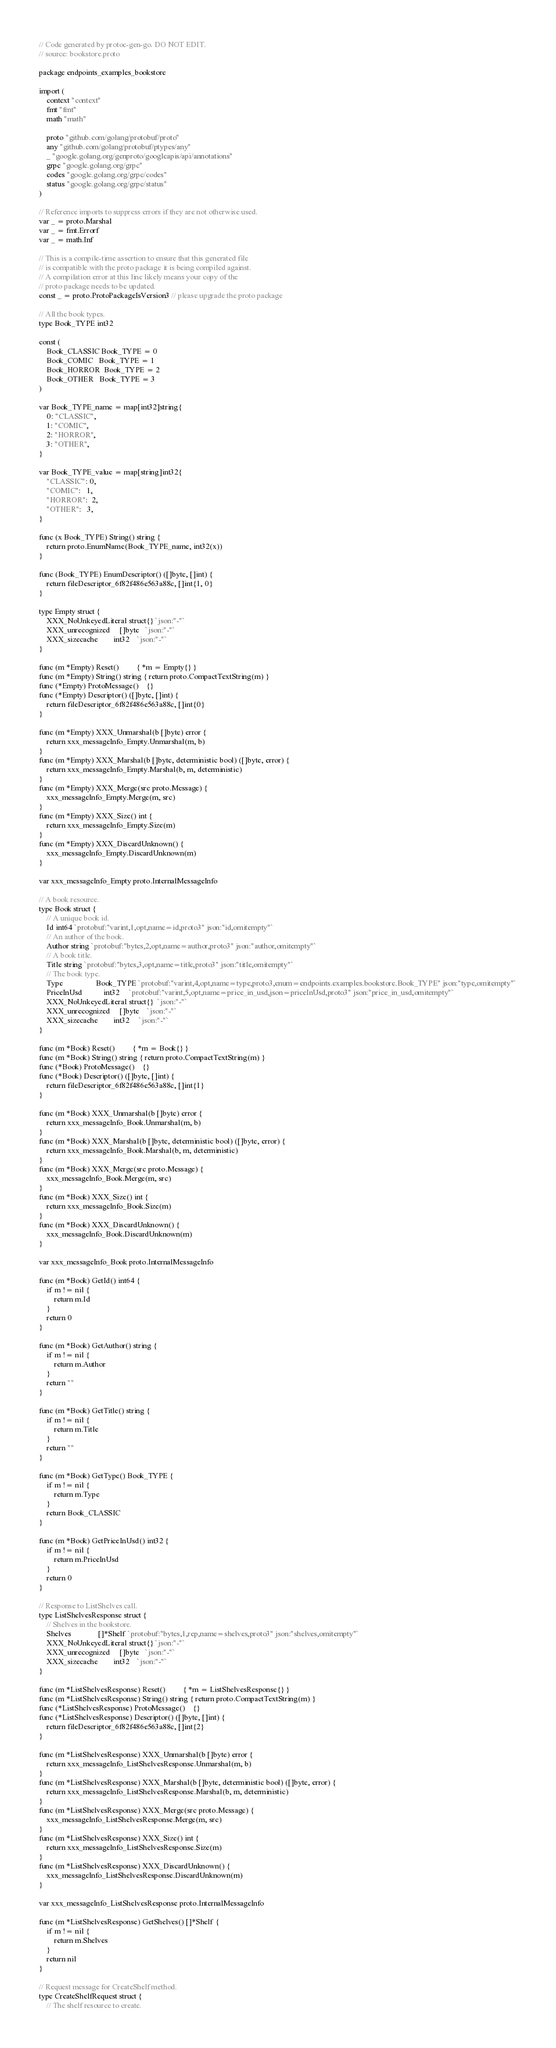Convert code to text. <code><loc_0><loc_0><loc_500><loc_500><_Go_>// Code generated by protoc-gen-go. DO NOT EDIT.
// source: bookstore.proto

package endpoints_examples_bookstore

import (
	context "context"
	fmt "fmt"
	math "math"

	proto "github.com/golang/protobuf/proto"
	any "github.com/golang/protobuf/ptypes/any"
	_ "google.golang.org/genproto/googleapis/api/annotations"
	grpc "google.golang.org/grpc"
	codes "google.golang.org/grpc/codes"
	status "google.golang.org/grpc/status"
)

// Reference imports to suppress errors if they are not otherwise used.
var _ = proto.Marshal
var _ = fmt.Errorf
var _ = math.Inf

// This is a compile-time assertion to ensure that this generated file
// is compatible with the proto package it is being compiled against.
// A compilation error at this line likely means your copy of the
// proto package needs to be updated.
const _ = proto.ProtoPackageIsVersion3 // please upgrade the proto package

// All the book types.
type Book_TYPE int32

const (
	Book_CLASSIC Book_TYPE = 0
	Book_COMIC   Book_TYPE = 1
	Book_HORROR  Book_TYPE = 2
	Book_OTHER   Book_TYPE = 3
)

var Book_TYPE_name = map[int32]string{
	0: "CLASSIC",
	1: "COMIC",
	2: "HORROR",
	3: "OTHER",
}

var Book_TYPE_value = map[string]int32{
	"CLASSIC": 0,
	"COMIC":   1,
	"HORROR":  2,
	"OTHER":   3,
}

func (x Book_TYPE) String() string {
	return proto.EnumName(Book_TYPE_name, int32(x))
}

func (Book_TYPE) EnumDescriptor() ([]byte, []int) {
	return fileDescriptor_6f82f486e563a88c, []int{1, 0}
}

type Empty struct {
	XXX_NoUnkeyedLiteral struct{} `json:"-"`
	XXX_unrecognized     []byte   `json:"-"`
	XXX_sizecache        int32    `json:"-"`
}

func (m *Empty) Reset()         { *m = Empty{} }
func (m *Empty) String() string { return proto.CompactTextString(m) }
func (*Empty) ProtoMessage()    {}
func (*Empty) Descriptor() ([]byte, []int) {
	return fileDescriptor_6f82f486e563a88c, []int{0}
}

func (m *Empty) XXX_Unmarshal(b []byte) error {
	return xxx_messageInfo_Empty.Unmarshal(m, b)
}
func (m *Empty) XXX_Marshal(b []byte, deterministic bool) ([]byte, error) {
	return xxx_messageInfo_Empty.Marshal(b, m, deterministic)
}
func (m *Empty) XXX_Merge(src proto.Message) {
	xxx_messageInfo_Empty.Merge(m, src)
}
func (m *Empty) XXX_Size() int {
	return xxx_messageInfo_Empty.Size(m)
}
func (m *Empty) XXX_DiscardUnknown() {
	xxx_messageInfo_Empty.DiscardUnknown(m)
}

var xxx_messageInfo_Empty proto.InternalMessageInfo

// A book resource.
type Book struct {
	// A unique book id.
	Id int64 `protobuf:"varint,1,opt,name=id,proto3" json:"id,omitempty"`
	// An author of the book.
	Author string `protobuf:"bytes,2,opt,name=author,proto3" json:"author,omitempty"`
	// A book title.
	Title string `protobuf:"bytes,3,opt,name=title,proto3" json:"title,omitempty"`
	// The book type.
	Type                 Book_TYPE `protobuf:"varint,4,opt,name=type,proto3,enum=endpoints.examples.bookstore.Book_TYPE" json:"type,omitempty"`
	PriceInUsd           int32     `protobuf:"varint,5,opt,name=price_in_usd,json=priceInUsd,proto3" json:"price_in_usd,omitempty"`
	XXX_NoUnkeyedLiteral struct{}  `json:"-"`
	XXX_unrecognized     []byte    `json:"-"`
	XXX_sizecache        int32     `json:"-"`
}

func (m *Book) Reset()         { *m = Book{} }
func (m *Book) String() string { return proto.CompactTextString(m) }
func (*Book) ProtoMessage()    {}
func (*Book) Descriptor() ([]byte, []int) {
	return fileDescriptor_6f82f486e563a88c, []int{1}
}

func (m *Book) XXX_Unmarshal(b []byte) error {
	return xxx_messageInfo_Book.Unmarshal(m, b)
}
func (m *Book) XXX_Marshal(b []byte, deterministic bool) ([]byte, error) {
	return xxx_messageInfo_Book.Marshal(b, m, deterministic)
}
func (m *Book) XXX_Merge(src proto.Message) {
	xxx_messageInfo_Book.Merge(m, src)
}
func (m *Book) XXX_Size() int {
	return xxx_messageInfo_Book.Size(m)
}
func (m *Book) XXX_DiscardUnknown() {
	xxx_messageInfo_Book.DiscardUnknown(m)
}

var xxx_messageInfo_Book proto.InternalMessageInfo

func (m *Book) GetId() int64 {
	if m != nil {
		return m.Id
	}
	return 0
}

func (m *Book) GetAuthor() string {
	if m != nil {
		return m.Author
	}
	return ""
}

func (m *Book) GetTitle() string {
	if m != nil {
		return m.Title
	}
	return ""
}

func (m *Book) GetType() Book_TYPE {
	if m != nil {
		return m.Type
	}
	return Book_CLASSIC
}

func (m *Book) GetPriceInUsd() int32 {
	if m != nil {
		return m.PriceInUsd
	}
	return 0
}

// Response to ListShelves call.
type ListShelvesResponse struct {
	// Shelves in the bookstore.
	Shelves              []*Shelf `protobuf:"bytes,1,rep,name=shelves,proto3" json:"shelves,omitempty"`
	XXX_NoUnkeyedLiteral struct{} `json:"-"`
	XXX_unrecognized     []byte   `json:"-"`
	XXX_sizecache        int32    `json:"-"`
}

func (m *ListShelvesResponse) Reset()         { *m = ListShelvesResponse{} }
func (m *ListShelvesResponse) String() string { return proto.CompactTextString(m) }
func (*ListShelvesResponse) ProtoMessage()    {}
func (*ListShelvesResponse) Descriptor() ([]byte, []int) {
	return fileDescriptor_6f82f486e563a88c, []int{2}
}

func (m *ListShelvesResponse) XXX_Unmarshal(b []byte) error {
	return xxx_messageInfo_ListShelvesResponse.Unmarshal(m, b)
}
func (m *ListShelvesResponse) XXX_Marshal(b []byte, deterministic bool) ([]byte, error) {
	return xxx_messageInfo_ListShelvesResponse.Marshal(b, m, deterministic)
}
func (m *ListShelvesResponse) XXX_Merge(src proto.Message) {
	xxx_messageInfo_ListShelvesResponse.Merge(m, src)
}
func (m *ListShelvesResponse) XXX_Size() int {
	return xxx_messageInfo_ListShelvesResponse.Size(m)
}
func (m *ListShelvesResponse) XXX_DiscardUnknown() {
	xxx_messageInfo_ListShelvesResponse.DiscardUnknown(m)
}

var xxx_messageInfo_ListShelvesResponse proto.InternalMessageInfo

func (m *ListShelvesResponse) GetShelves() []*Shelf {
	if m != nil {
		return m.Shelves
	}
	return nil
}

// Request message for CreateShelf method.
type CreateShelfRequest struct {
	// The shelf resource to create.</code> 